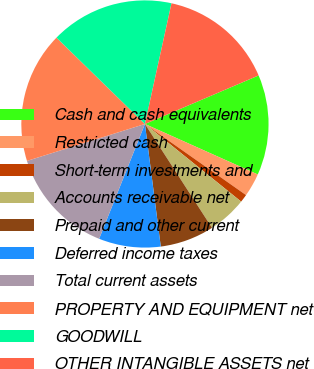Convert chart to OTSL. <chart><loc_0><loc_0><loc_500><loc_500><pie_chart><fcel>Cash and cash equivalents<fcel>Restricted cash<fcel>Short-term investments and<fcel>Accounts receivable net<fcel>Prepaid and other current<fcel>Deferred income taxes<fcel>Total current assets<fcel>PROPERTY AND EQUIPMENT net<fcel>GOODWILL<fcel>OTHER INTANGIBLE ASSETS net<nl><fcel>13.12%<fcel>3.06%<fcel>1.05%<fcel>5.07%<fcel>7.08%<fcel>8.09%<fcel>14.13%<fcel>17.14%<fcel>16.14%<fcel>15.13%<nl></chart> 